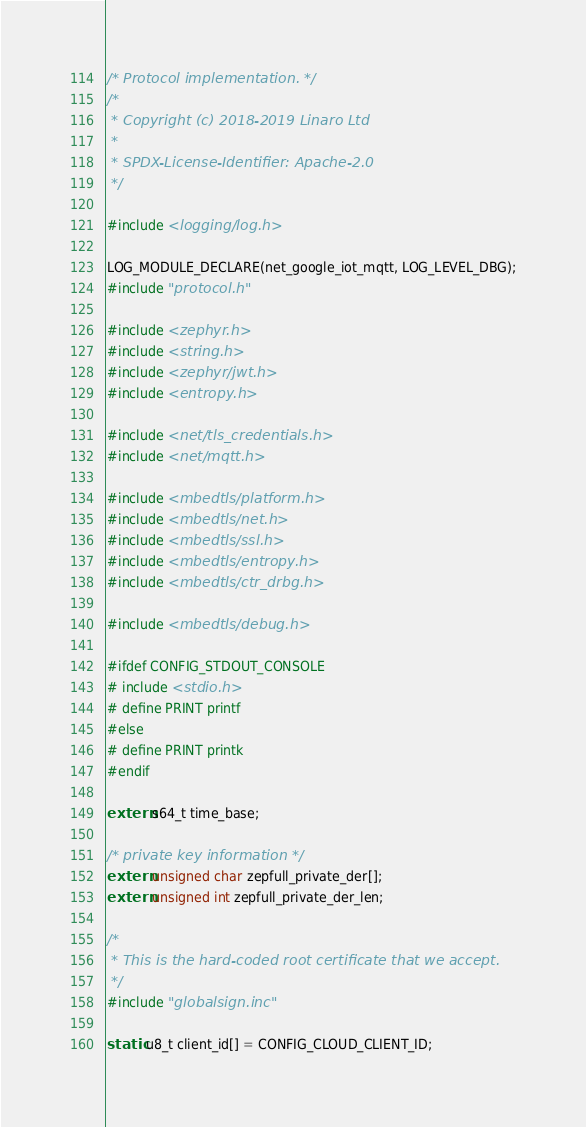<code> <loc_0><loc_0><loc_500><loc_500><_C_>/* Protocol implementation. */
/*
 * Copyright (c) 2018-2019 Linaro Ltd
 *
 * SPDX-License-Identifier: Apache-2.0
 */

#include <logging/log.h>

LOG_MODULE_DECLARE(net_google_iot_mqtt, LOG_LEVEL_DBG);
#include "protocol.h"

#include <zephyr.h>
#include <string.h>
#include <zephyr/jwt.h>
#include <entropy.h>

#include <net/tls_credentials.h>
#include <net/mqtt.h>

#include <mbedtls/platform.h>
#include <mbedtls/net.h>
#include <mbedtls/ssl.h>
#include <mbedtls/entropy.h>
#include <mbedtls/ctr_drbg.h>

#include <mbedtls/debug.h>

#ifdef CONFIG_STDOUT_CONSOLE
# include <stdio.h>
# define PRINT printf
#else
# define PRINT printk
#endif

extern s64_t time_base;

/* private key information */
extern unsigned char zepfull_private_der[];
extern unsigned int zepfull_private_der_len;

/*
 * This is the hard-coded root certificate that we accept.
 */
#include "globalsign.inc"

static u8_t client_id[] = CONFIG_CLOUD_CLIENT_ID;</code> 